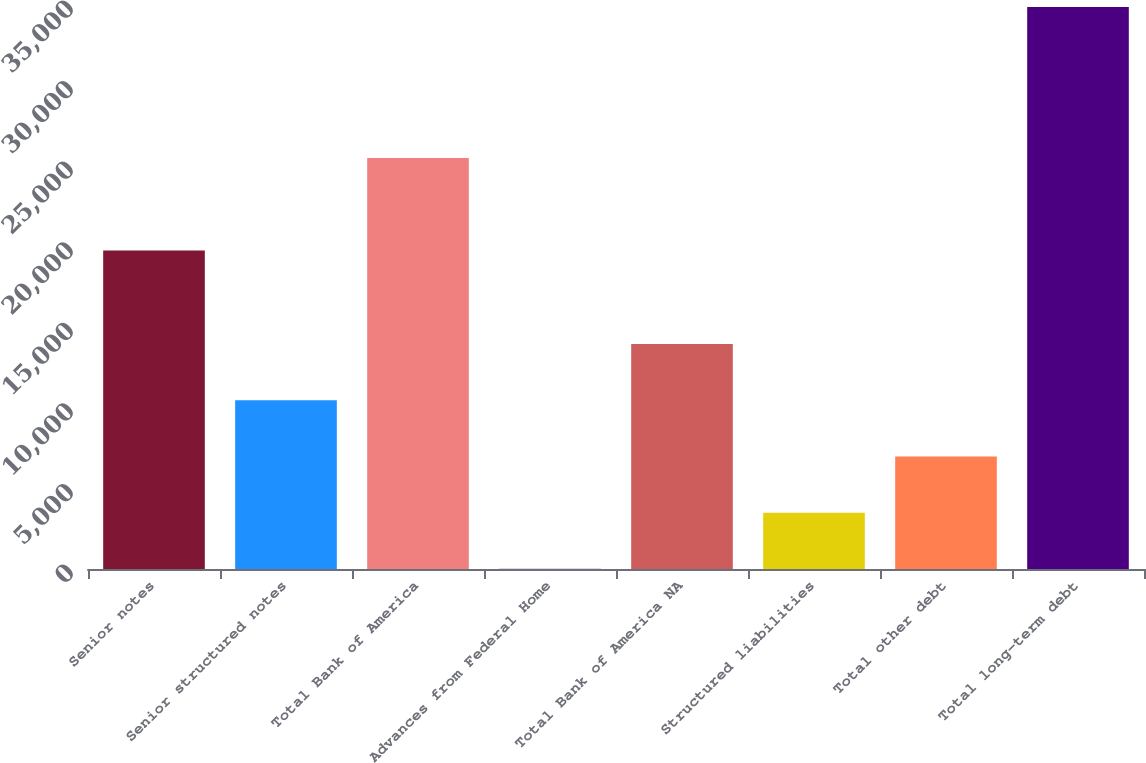Convert chart to OTSL. <chart><loc_0><loc_0><loc_500><loc_500><bar_chart><fcel>Senior notes<fcel>Senior structured notes<fcel>Total Bank of America<fcel>Advances from Federal Home<fcel>Total Bank of America NA<fcel>Structured liabilities<fcel>Total other debt<fcel>Total long-term debt<nl><fcel>19765<fcel>10470.3<fcel>25505<fcel>9<fcel>13957.4<fcel>3496.1<fcel>6983.2<fcel>34880<nl></chart> 